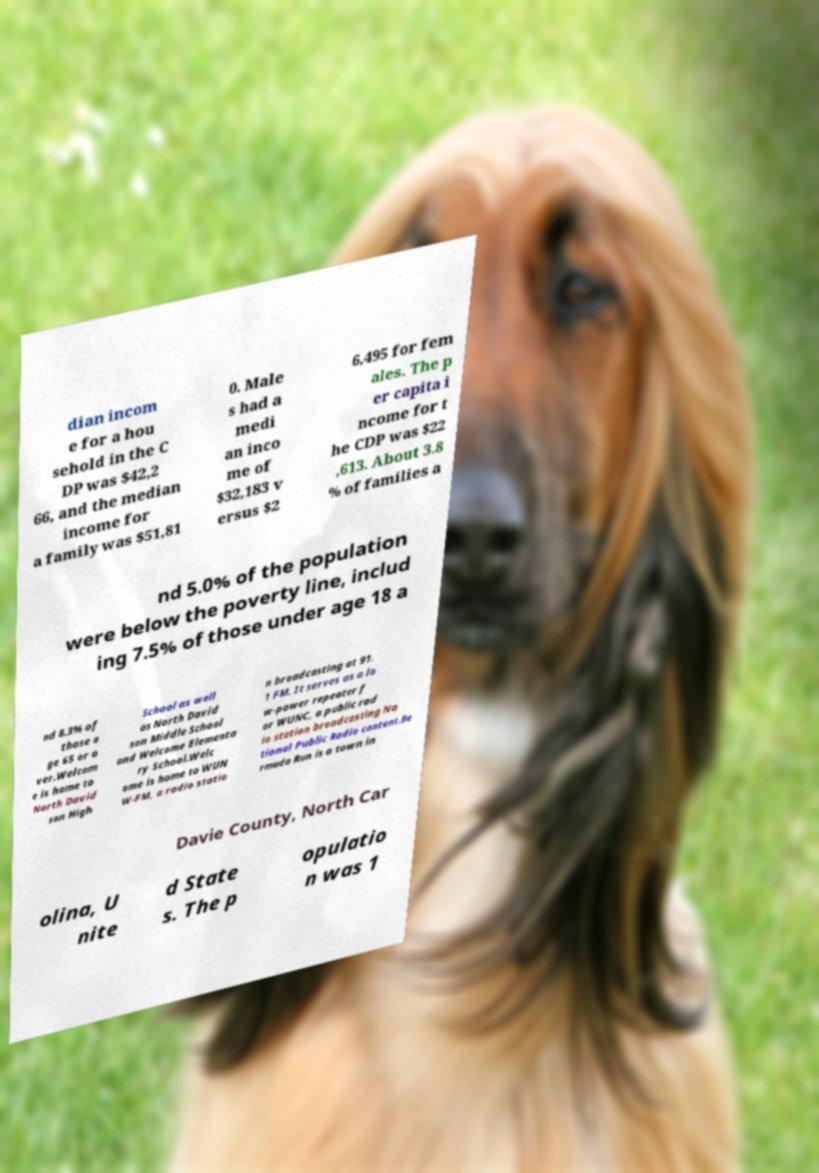For documentation purposes, I need the text within this image transcribed. Could you provide that? dian incom e for a hou sehold in the C DP was $42,2 66, and the median income for a family was $51,81 0. Male s had a medi an inco me of $32,183 v ersus $2 6,495 for fem ales. The p er capita i ncome for t he CDP was $22 ,613. About 3.8 % of families a nd 5.0% of the population were below the poverty line, includ ing 7.5% of those under age 18 a nd 8.3% of those a ge 65 or o ver.Welcom e is home to North David son High School as well as North David son Middle School and Welcome Elementa ry School.Welc ome is home to WUN W-FM, a radio statio n broadcasting at 91. 1 FM. It serves as a lo w-power repeater f or WUNC, a public rad io station broadcasting Na tional Public Radio content.Be rmuda Run is a town in Davie County, North Car olina, U nite d State s. The p opulatio n was 1 